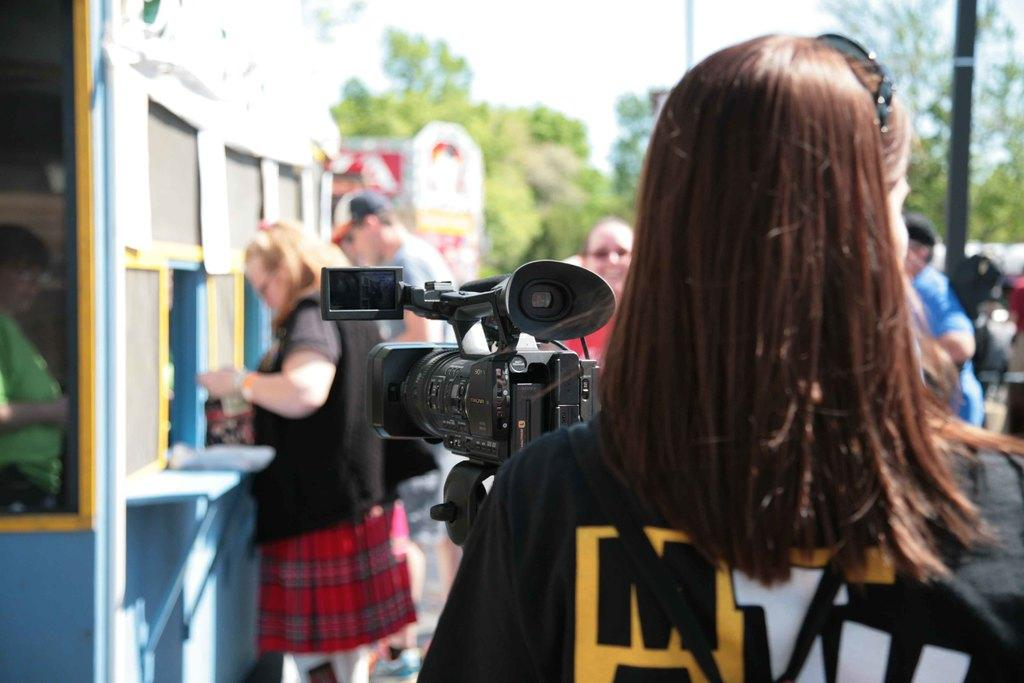What is the main subject of the image? There is a person standing in front of a camera. Can you describe the background of the image? There are more people, buildings, and trees visible at the back of the image. Is there any blood visible on the person standing in front of the camera? No, there is no blood visible on the person standing in front of the camera. Can you see a tiger hiding behind the trees in the image? No, there is no tiger present in the image. 